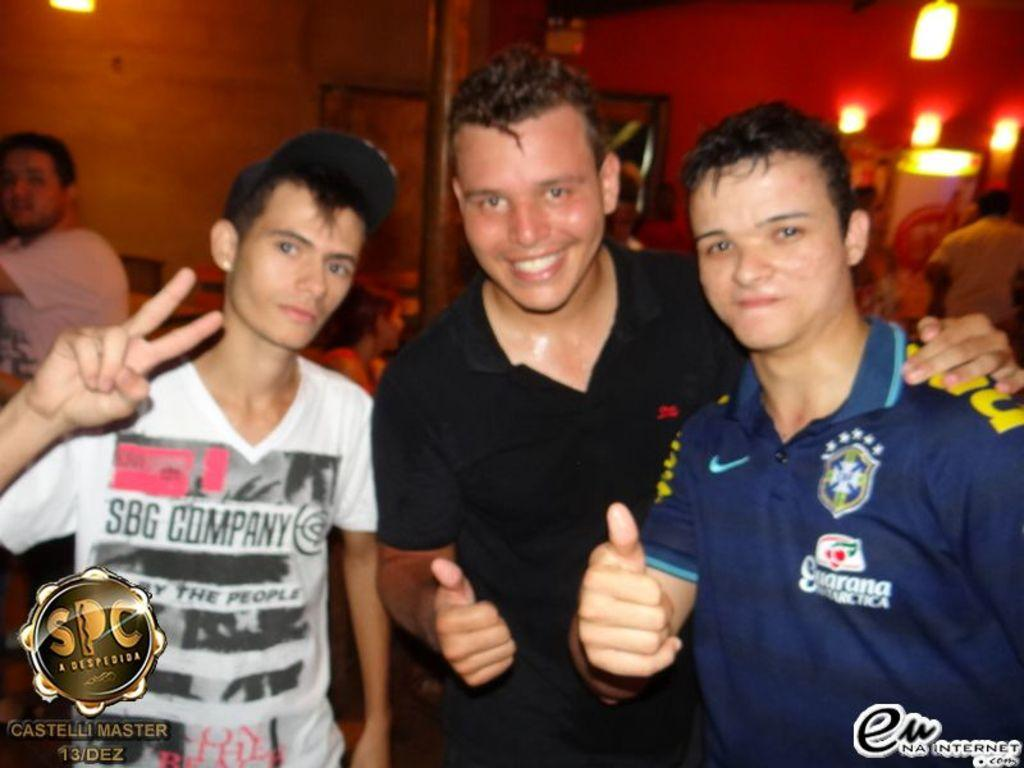How many people are in the image? There are three persons standing in the image. What is the facial expression of the people in the image? All three persons are smiling. Can you describe the clothing of the person on the left? The person on the left is wearing a cap. What can be seen in the background of the image? There are lights visible in the background of the image. Are there any marks or identifiers on the image itself? Yes, there are watermarks in the bottom corners of the image. Can you tell me how many rabbits are hopping around in the image? There are no rabbits present in the image; it features three people standing and smiling. What type of worm is crawling on the person on the right? There are no worms present in the image; the person on the right is not interacting with any creatures. 